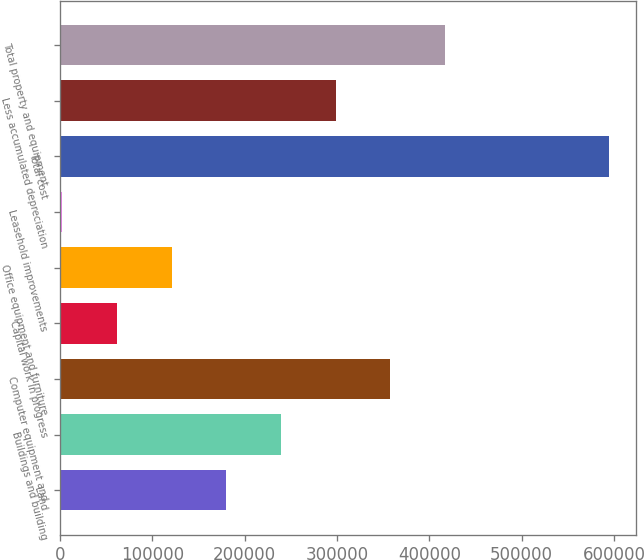Convert chart to OTSL. <chart><loc_0><loc_0><loc_500><loc_500><bar_chart><fcel>Land<fcel>Buildings and building<fcel>Computer equipment and<fcel>Capital work in progress<fcel>Office equipment and furniture<fcel>Leasehold improvements<fcel>Total cost<fcel>Less accumulated depreciation<fcel>Total property and equipment<nl><fcel>179867<fcel>239280<fcel>357670<fcel>61477<fcel>120672<fcel>2282<fcel>594232<fcel>298475<fcel>416865<nl></chart> 